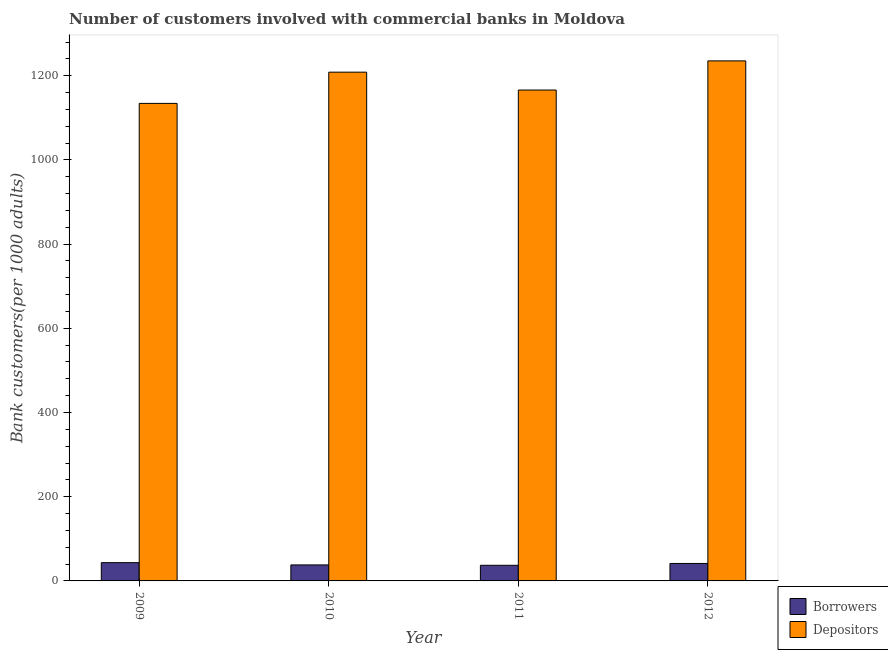How many different coloured bars are there?
Provide a short and direct response. 2. Are the number of bars per tick equal to the number of legend labels?
Provide a short and direct response. Yes. Are the number of bars on each tick of the X-axis equal?
Your answer should be very brief. Yes. How many bars are there on the 4th tick from the left?
Your answer should be compact. 2. How many bars are there on the 2nd tick from the right?
Your response must be concise. 2. What is the label of the 4th group of bars from the left?
Offer a very short reply. 2012. What is the number of depositors in 2010?
Offer a terse response. 1208.39. Across all years, what is the maximum number of depositors?
Make the answer very short. 1235.18. Across all years, what is the minimum number of depositors?
Make the answer very short. 1134.17. What is the total number of borrowers in the graph?
Your response must be concise. 159.99. What is the difference between the number of depositors in 2010 and that in 2012?
Your response must be concise. -26.79. What is the difference between the number of borrowers in 2012 and the number of depositors in 2010?
Offer a very short reply. 3.43. What is the average number of depositors per year?
Your answer should be very brief. 1185.92. In the year 2009, what is the difference between the number of depositors and number of borrowers?
Ensure brevity in your answer.  0. In how many years, is the number of borrowers greater than 1000?
Keep it short and to the point. 0. What is the ratio of the number of depositors in 2011 to that in 2012?
Offer a very short reply. 0.94. Is the difference between the number of depositors in 2010 and 2012 greater than the difference between the number of borrowers in 2010 and 2012?
Keep it short and to the point. No. What is the difference between the highest and the second highest number of borrowers?
Provide a short and direct response. 1.91. What is the difference between the highest and the lowest number of depositors?
Ensure brevity in your answer.  101.01. Is the sum of the number of borrowers in 2011 and 2012 greater than the maximum number of depositors across all years?
Offer a terse response. Yes. What does the 2nd bar from the left in 2011 represents?
Your response must be concise. Depositors. What does the 2nd bar from the right in 2010 represents?
Give a very brief answer. Borrowers. How many bars are there?
Keep it short and to the point. 8. Are all the bars in the graph horizontal?
Provide a short and direct response. No. How many years are there in the graph?
Offer a very short reply. 4. What is the difference between two consecutive major ticks on the Y-axis?
Make the answer very short. 200. Are the values on the major ticks of Y-axis written in scientific E-notation?
Keep it short and to the point. No. Where does the legend appear in the graph?
Keep it short and to the point. Bottom right. How are the legend labels stacked?
Give a very brief answer. Vertical. What is the title of the graph?
Give a very brief answer. Number of customers involved with commercial banks in Moldova. Does "Commercial service exports" appear as one of the legend labels in the graph?
Keep it short and to the point. No. What is the label or title of the Y-axis?
Make the answer very short. Bank customers(per 1000 adults). What is the Bank customers(per 1000 adults) of Borrowers in 2009?
Ensure brevity in your answer.  43.38. What is the Bank customers(per 1000 adults) in Depositors in 2009?
Your response must be concise. 1134.17. What is the Bank customers(per 1000 adults) in Borrowers in 2010?
Make the answer very short. 38.03. What is the Bank customers(per 1000 adults) in Depositors in 2010?
Offer a very short reply. 1208.39. What is the Bank customers(per 1000 adults) in Borrowers in 2011?
Keep it short and to the point. 37.11. What is the Bank customers(per 1000 adults) in Depositors in 2011?
Provide a short and direct response. 1165.93. What is the Bank customers(per 1000 adults) in Borrowers in 2012?
Offer a terse response. 41.47. What is the Bank customers(per 1000 adults) of Depositors in 2012?
Make the answer very short. 1235.18. Across all years, what is the maximum Bank customers(per 1000 adults) in Borrowers?
Provide a short and direct response. 43.38. Across all years, what is the maximum Bank customers(per 1000 adults) in Depositors?
Offer a very short reply. 1235.18. Across all years, what is the minimum Bank customers(per 1000 adults) in Borrowers?
Offer a very short reply. 37.11. Across all years, what is the minimum Bank customers(per 1000 adults) of Depositors?
Your answer should be very brief. 1134.17. What is the total Bank customers(per 1000 adults) of Borrowers in the graph?
Provide a succinct answer. 159.99. What is the total Bank customers(per 1000 adults) in Depositors in the graph?
Your answer should be compact. 4743.68. What is the difference between the Bank customers(per 1000 adults) of Borrowers in 2009 and that in 2010?
Provide a succinct answer. 5.34. What is the difference between the Bank customers(per 1000 adults) of Depositors in 2009 and that in 2010?
Offer a terse response. -74.22. What is the difference between the Bank customers(per 1000 adults) of Borrowers in 2009 and that in 2011?
Keep it short and to the point. 6.26. What is the difference between the Bank customers(per 1000 adults) of Depositors in 2009 and that in 2011?
Keep it short and to the point. -31.76. What is the difference between the Bank customers(per 1000 adults) of Borrowers in 2009 and that in 2012?
Your answer should be very brief. 1.91. What is the difference between the Bank customers(per 1000 adults) in Depositors in 2009 and that in 2012?
Offer a very short reply. -101.01. What is the difference between the Bank customers(per 1000 adults) in Borrowers in 2010 and that in 2011?
Provide a succinct answer. 0.92. What is the difference between the Bank customers(per 1000 adults) in Depositors in 2010 and that in 2011?
Offer a very short reply. 42.46. What is the difference between the Bank customers(per 1000 adults) in Borrowers in 2010 and that in 2012?
Offer a terse response. -3.43. What is the difference between the Bank customers(per 1000 adults) in Depositors in 2010 and that in 2012?
Offer a very short reply. -26.79. What is the difference between the Bank customers(per 1000 adults) in Borrowers in 2011 and that in 2012?
Your answer should be compact. -4.35. What is the difference between the Bank customers(per 1000 adults) in Depositors in 2011 and that in 2012?
Your answer should be compact. -69.25. What is the difference between the Bank customers(per 1000 adults) of Borrowers in 2009 and the Bank customers(per 1000 adults) of Depositors in 2010?
Give a very brief answer. -1165.01. What is the difference between the Bank customers(per 1000 adults) in Borrowers in 2009 and the Bank customers(per 1000 adults) in Depositors in 2011?
Keep it short and to the point. -1122.55. What is the difference between the Bank customers(per 1000 adults) of Borrowers in 2009 and the Bank customers(per 1000 adults) of Depositors in 2012?
Ensure brevity in your answer.  -1191.81. What is the difference between the Bank customers(per 1000 adults) in Borrowers in 2010 and the Bank customers(per 1000 adults) in Depositors in 2011?
Keep it short and to the point. -1127.9. What is the difference between the Bank customers(per 1000 adults) of Borrowers in 2010 and the Bank customers(per 1000 adults) of Depositors in 2012?
Make the answer very short. -1197.15. What is the difference between the Bank customers(per 1000 adults) of Borrowers in 2011 and the Bank customers(per 1000 adults) of Depositors in 2012?
Make the answer very short. -1198.07. What is the average Bank customers(per 1000 adults) in Borrowers per year?
Offer a terse response. 40. What is the average Bank customers(per 1000 adults) in Depositors per year?
Offer a very short reply. 1185.92. In the year 2009, what is the difference between the Bank customers(per 1000 adults) of Borrowers and Bank customers(per 1000 adults) of Depositors?
Your answer should be compact. -1090.8. In the year 2010, what is the difference between the Bank customers(per 1000 adults) in Borrowers and Bank customers(per 1000 adults) in Depositors?
Your response must be concise. -1170.36. In the year 2011, what is the difference between the Bank customers(per 1000 adults) in Borrowers and Bank customers(per 1000 adults) in Depositors?
Your response must be concise. -1128.82. In the year 2012, what is the difference between the Bank customers(per 1000 adults) in Borrowers and Bank customers(per 1000 adults) in Depositors?
Your answer should be compact. -1193.72. What is the ratio of the Bank customers(per 1000 adults) of Borrowers in 2009 to that in 2010?
Make the answer very short. 1.14. What is the ratio of the Bank customers(per 1000 adults) in Depositors in 2009 to that in 2010?
Your response must be concise. 0.94. What is the ratio of the Bank customers(per 1000 adults) of Borrowers in 2009 to that in 2011?
Make the answer very short. 1.17. What is the ratio of the Bank customers(per 1000 adults) of Depositors in 2009 to that in 2011?
Give a very brief answer. 0.97. What is the ratio of the Bank customers(per 1000 adults) in Borrowers in 2009 to that in 2012?
Your response must be concise. 1.05. What is the ratio of the Bank customers(per 1000 adults) in Depositors in 2009 to that in 2012?
Provide a short and direct response. 0.92. What is the ratio of the Bank customers(per 1000 adults) in Borrowers in 2010 to that in 2011?
Your answer should be very brief. 1.02. What is the ratio of the Bank customers(per 1000 adults) of Depositors in 2010 to that in 2011?
Offer a very short reply. 1.04. What is the ratio of the Bank customers(per 1000 adults) in Borrowers in 2010 to that in 2012?
Offer a very short reply. 0.92. What is the ratio of the Bank customers(per 1000 adults) in Depositors in 2010 to that in 2012?
Give a very brief answer. 0.98. What is the ratio of the Bank customers(per 1000 adults) of Borrowers in 2011 to that in 2012?
Ensure brevity in your answer.  0.9. What is the ratio of the Bank customers(per 1000 adults) of Depositors in 2011 to that in 2012?
Offer a terse response. 0.94. What is the difference between the highest and the second highest Bank customers(per 1000 adults) in Borrowers?
Offer a terse response. 1.91. What is the difference between the highest and the second highest Bank customers(per 1000 adults) in Depositors?
Give a very brief answer. 26.79. What is the difference between the highest and the lowest Bank customers(per 1000 adults) of Borrowers?
Your answer should be very brief. 6.26. What is the difference between the highest and the lowest Bank customers(per 1000 adults) of Depositors?
Make the answer very short. 101.01. 